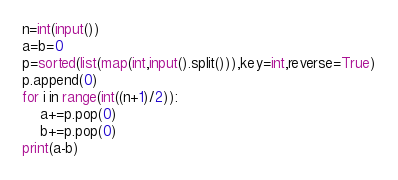<code> <loc_0><loc_0><loc_500><loc_500><_Python_>n=int(input())
a=b=0
p=sorted(list(map(int,input().split())),key=int,reverse=True)
p.append(0)
for i in range(int((n+1)/2)):
    a+=p.pop(0)
    b+=p.pop(0)
print(a-b)</code> 